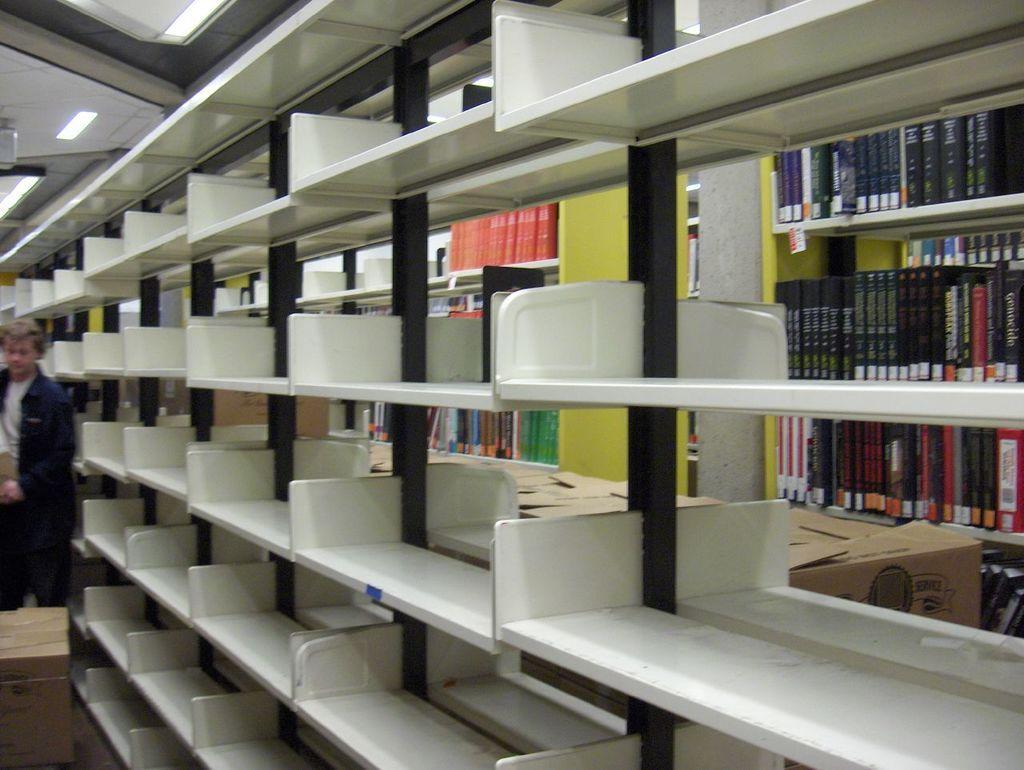Can you describe this image briefly? In this picture I can see the shelf. On the left there is a man who is standing near to the table. On the right I can see many books which are kept in the wooden shelf. Beside that I can see the wooden boxes. In the top left corner I can see the tube lights which are placed on the roof. 